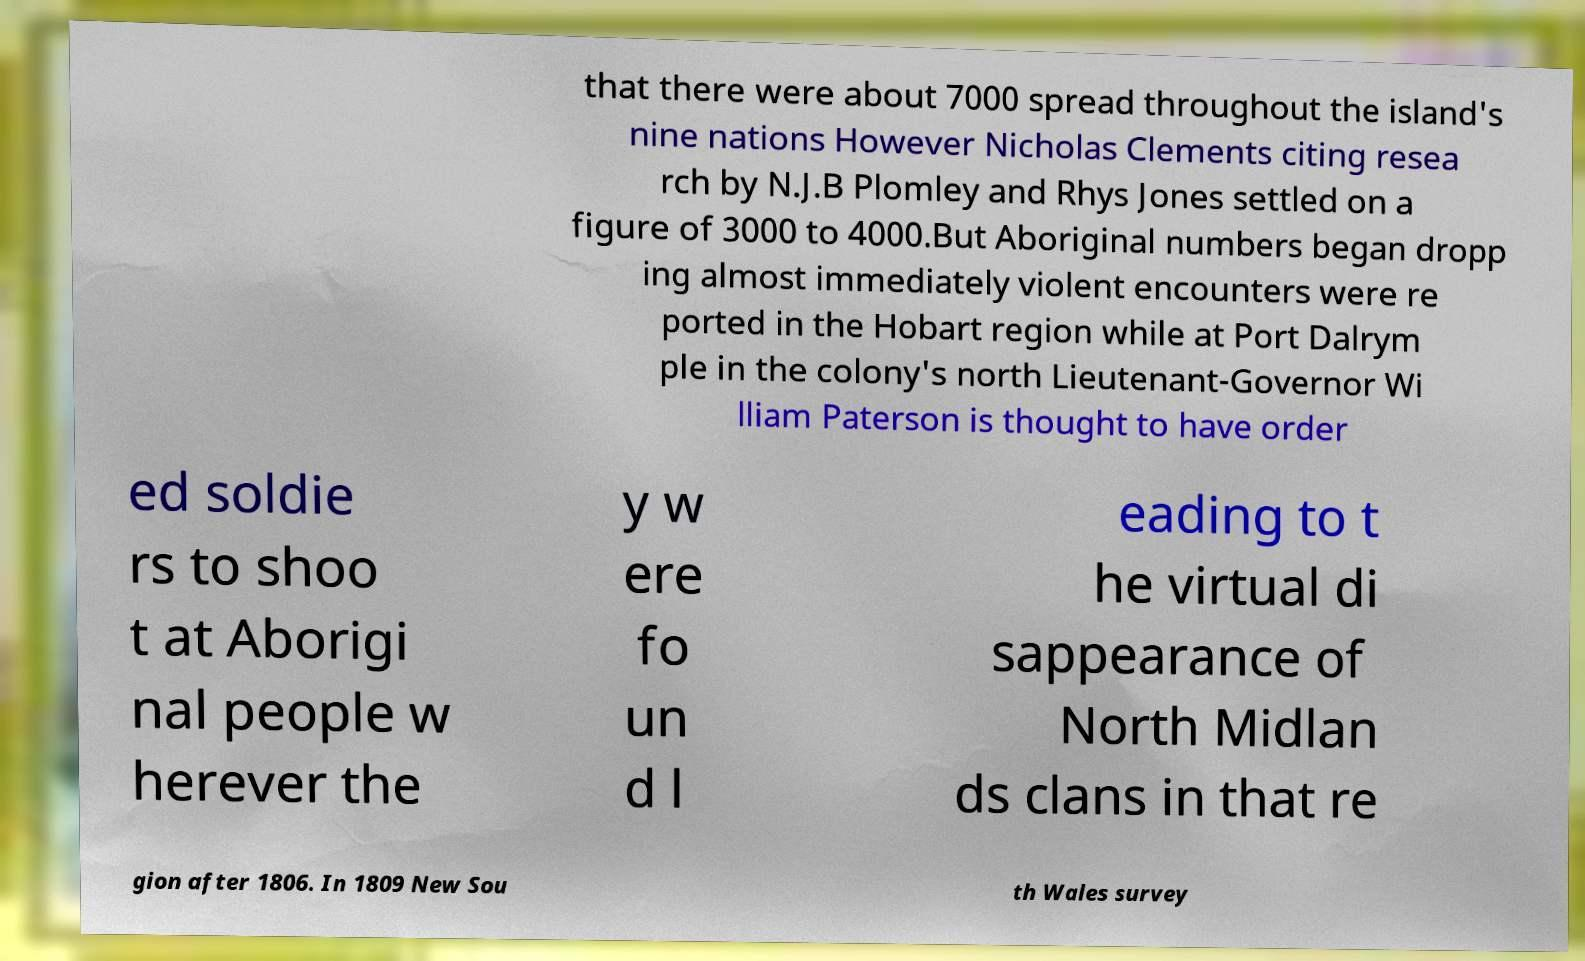Can you read and provide the text displayed in the image?This photo seems to have some interesting text. Can you extract and type it out for me? that there were about 7000 spread throughout the island's nine nations However Nicholas Clements citing resea rch by N.J.B Plomley and Rhys Jones settled on a figure of 3000 to 4000.But Aboriginal numbers began dropp ing almost immediately violent encounters were re ported in the Hobart region while at Port Dalrym ple in the colony's north Lieutenant-Governor Wi lliam Paterson is thought to have order ed soldie rs to shoo t at Aborigi nal people w herever the y w ere fo un d l eading to t he virtual di sappearance of North Midlan ds clans in that re gion after 1806. In 1809 New Sou th Wales survey 